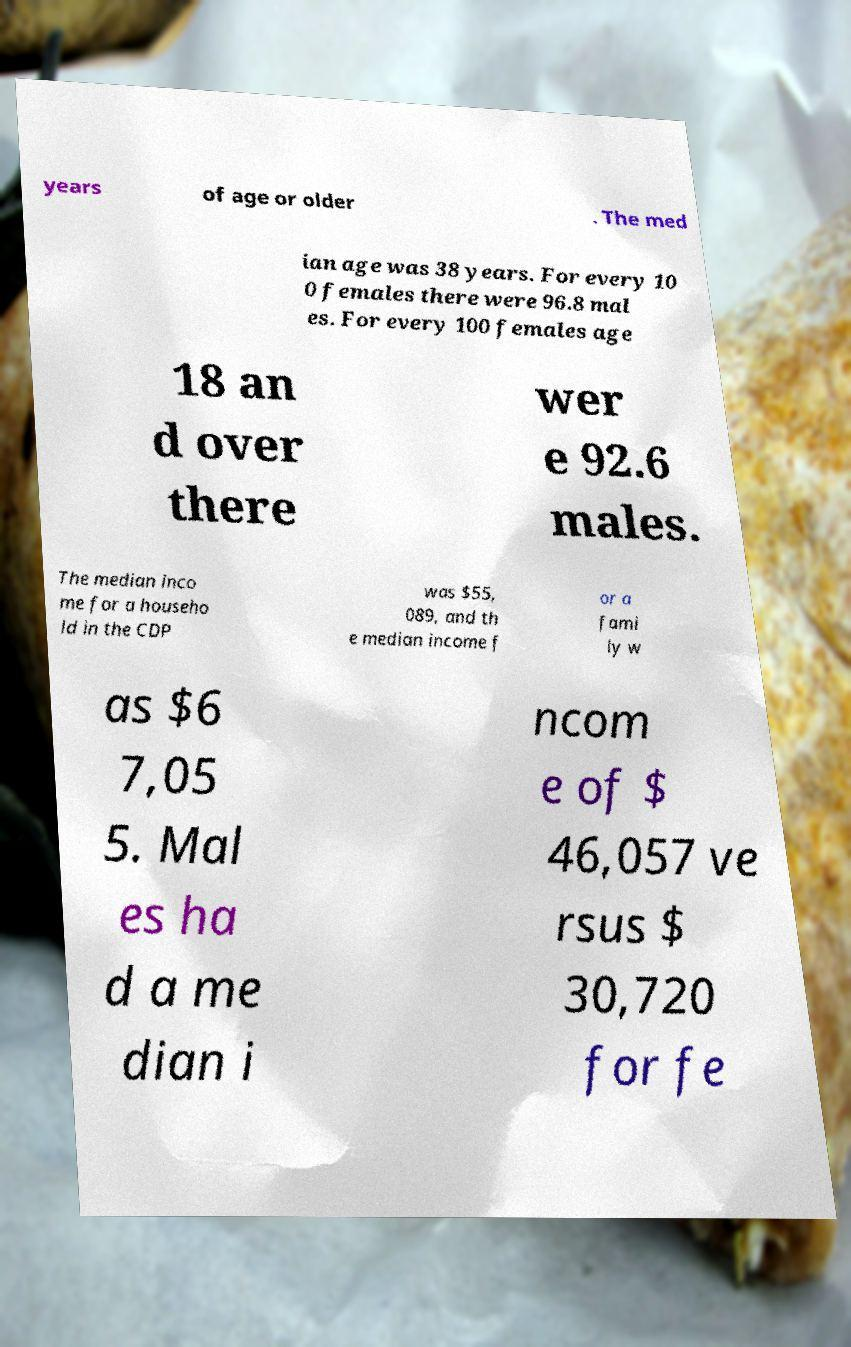Please identify and transcribe the text found in this image. years of age or older . The med ian age was 38 years. For every 10 0 females there were 96.8 mal es. For every 100 females age 18 an d over there wer e 92.6 males. The median inco me for a househo ld in the CDP was $55, 089, and th e median income f or a fami ly w as $6 7,05 5. Mal es ha d a me dian i ncom e of $ 46,057 ve rsus $ 30,720 for fe 